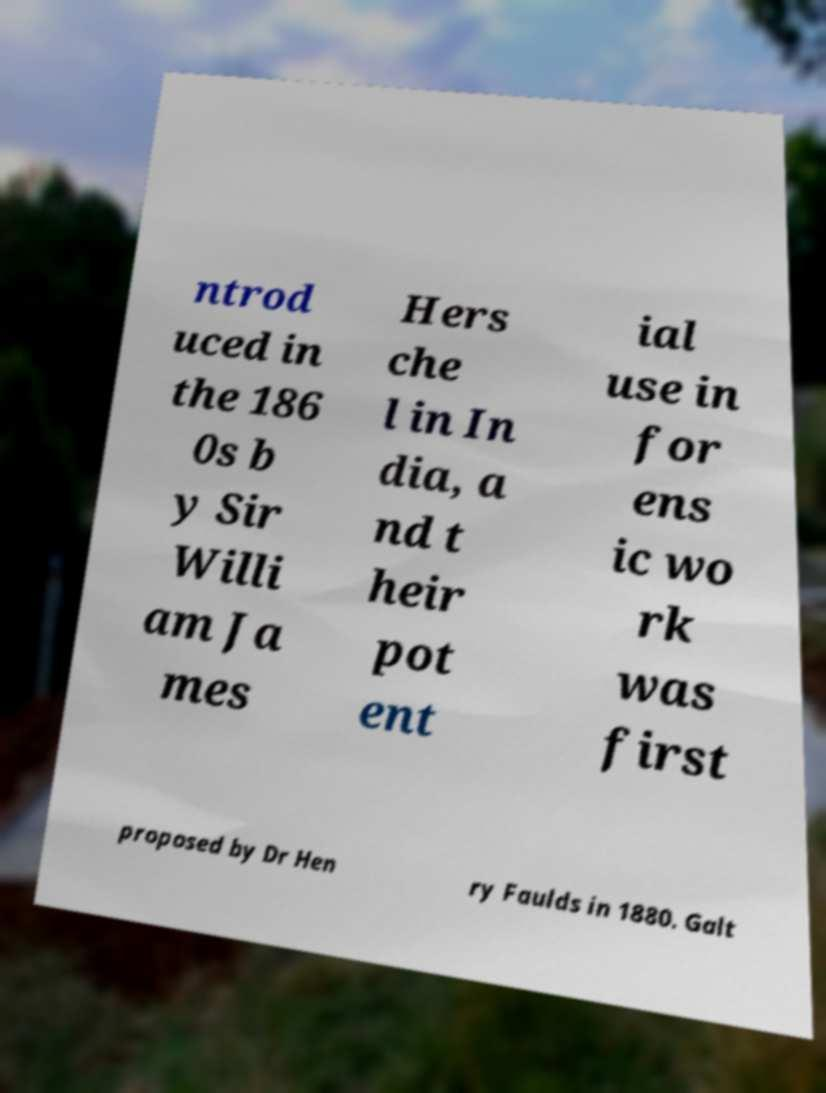Could you extract and type out the text from this image? ntrod uced in the 186 0s b y Sir Willi am Ja mes Hers che l in In dia, a nd t heir pot ent ial use in for ens ic wo rk was first proposed by Dr Hen ry Faulds in 1880. Galt 